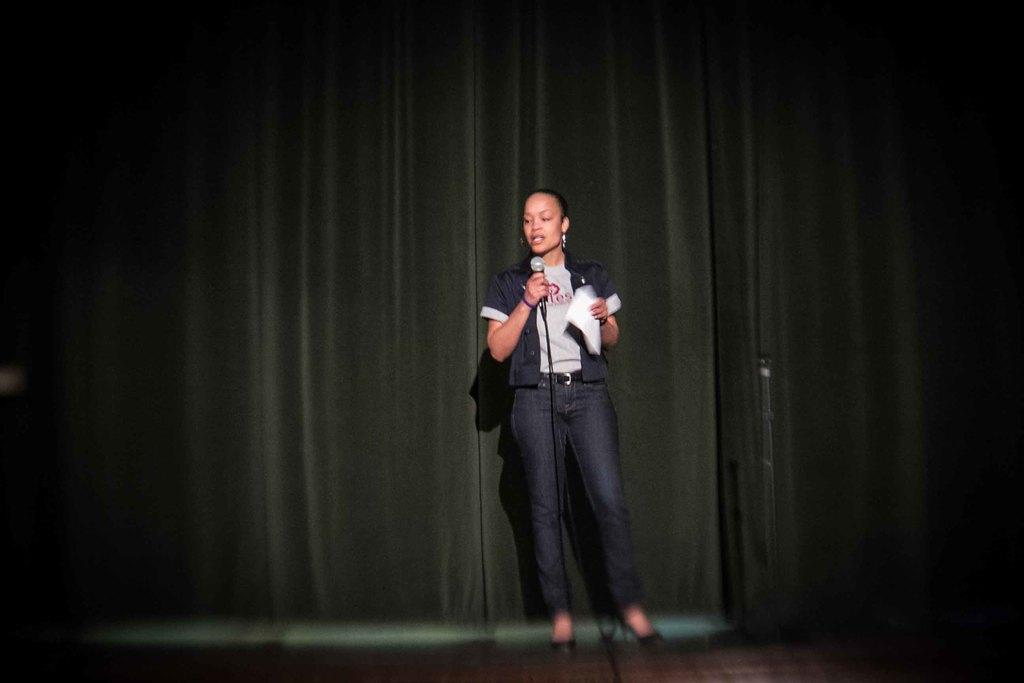Who is the main subject in the image? There is a woman in the image. What is the woman doing in the image? The woman is on the ground and holding a mic and a paper. What can be seen in the background of the image? There is a curtain in the background of the image. What type of bag is the woman using to cook in the image? There is no bag or cooking activity present in the image. 